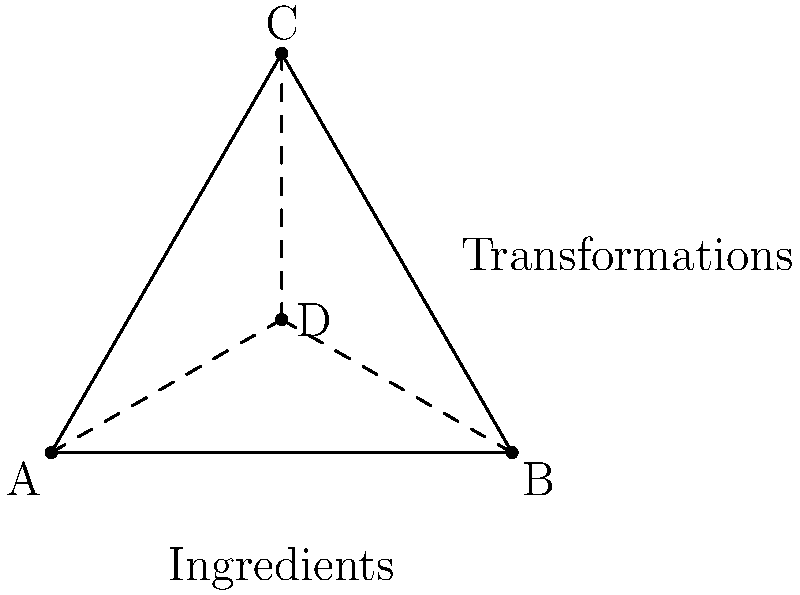In a chef's signature dish, three key ingredients (A, B, and C) undergo transformations represented by the triangle ABC. The chef introduces a secret ingredient (D) that interacts with the others. If the transformations form a group, which property is demonstrated by the dashed lines AD, BD, and CD in relation to the culinary process? To understand this culinary group theory problem, let's break it down step-by-step:

1. The triangle ABC represents the three key ingredients and their transformations in the dish.

2. Point D represents the secret ingredient introduced by the chef.

3. The dashed lines AD, BD, and CD represent the interactions between the secret ingredient and the other ingredients.

4. In group theory, this configuration is known as the medians of a triangle, where D is the centroid.

5. The centroid divides each median in a 2:1 ratio, meaning:
   $\overline{AD} : \overline{DC} = 2:1$
   $\overline{BD} : \overline{DC} = 2:1$
   $\overline{CD} : \overline{DC} = 2:1$

6. In the context of the culinary process, this represents the closure property of the group. The interaction of the secret ingredient with each of the other ingredients always results in a transformation that is still within the group (i.e., within the triangle).

7. The closure property ensures that combining or transforming elements within the group always produces another element within the same group.

8. In culinary terms, this means that no matter how the chef combines or transforms the ingredients, the result will always be consistent with the overall flavor profile and character of the signature dish.

Therefore, the dashed lines demonstrate the closure property of the group, ensuring the consistency and integrity of the chef's signature dish throughout the culinary process.
Answer: Closure property 